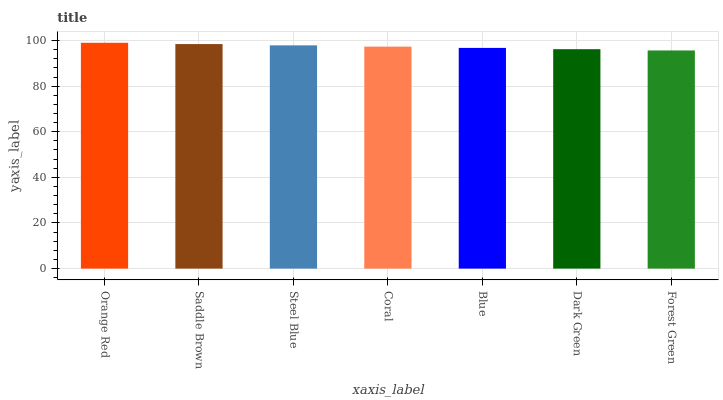Is Forest Green the minimum?
Answer yes or no. Yes. Is Orange Red the maximum?
Answer yes or no. Yes. Is Saddle Brown the minimum?
Answer yes or no. No. Is Saddle Brown the maximum?
Answer yes or no. No. Is Orange Red greater than Saddle Brown?
Answer yes or no. Yes. Is Saddle Brown less than Orange Red?
Answer yes or no. Yes. Is Saddle Brown greater than Orange Red?
Answer yes or no. No. Is Orange Red less than Saddle Brown?
Answer yes or no. No. Is Coral the high median?
Answer yes or no. Yes. Is Coral the low median?
Answer yes or no. Yes. Is Saddle Brown the high median?
Answer yes or no. No. Is Dark Green the low median?
Answer yes or no. No. 